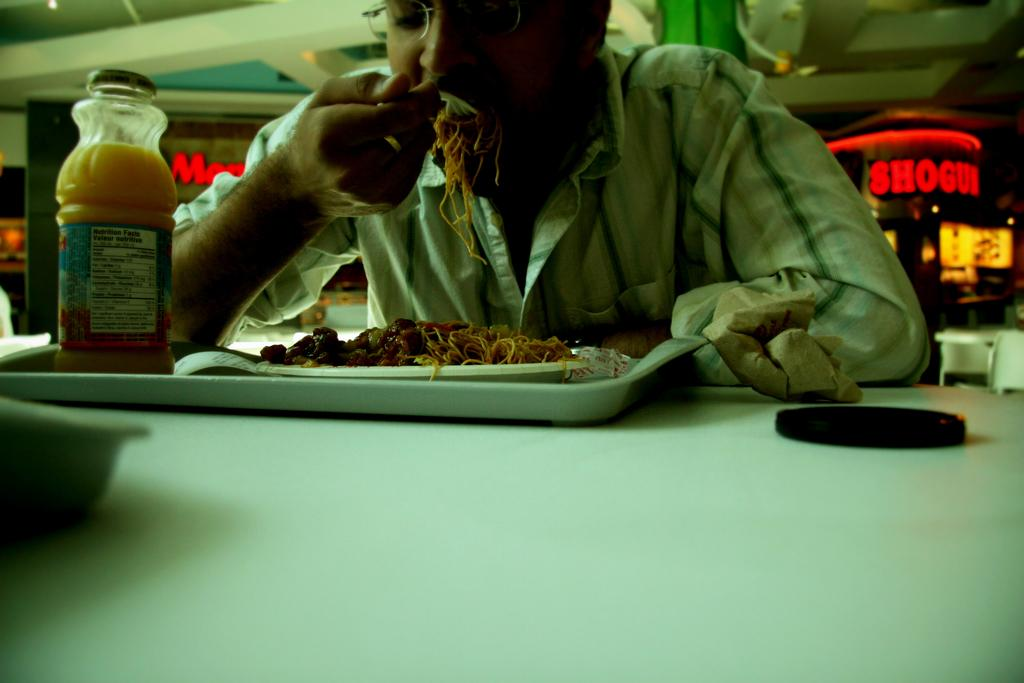<image>
Provide a brief description of the given image. An establishment  called Shogun can be seen behind a man eating noodles. 